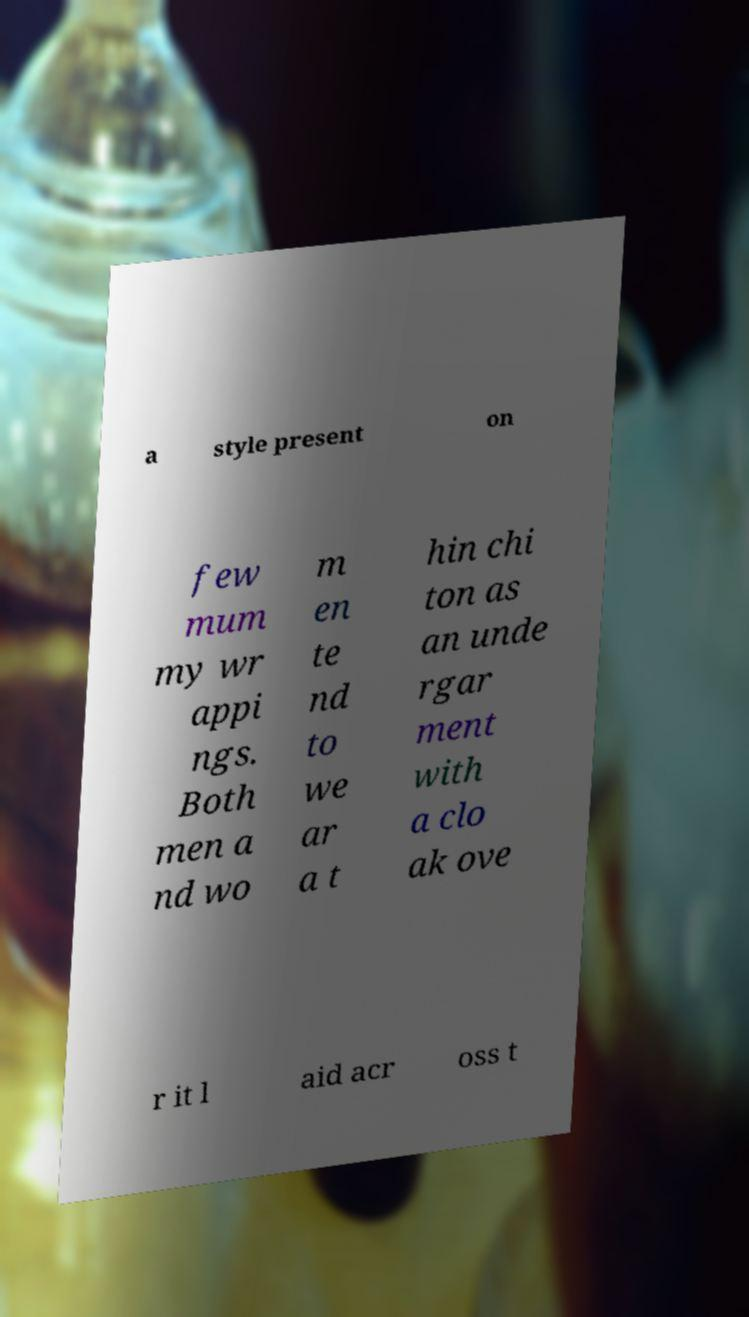I need the written content from this picture converted into text. Can you do that? a style present on few mum my wr appi ngs. Both men a nd wo m en te nd to we ar a t hin chi ton as an unde rgar ment with a clo ak ove r it l aid acr oss t 